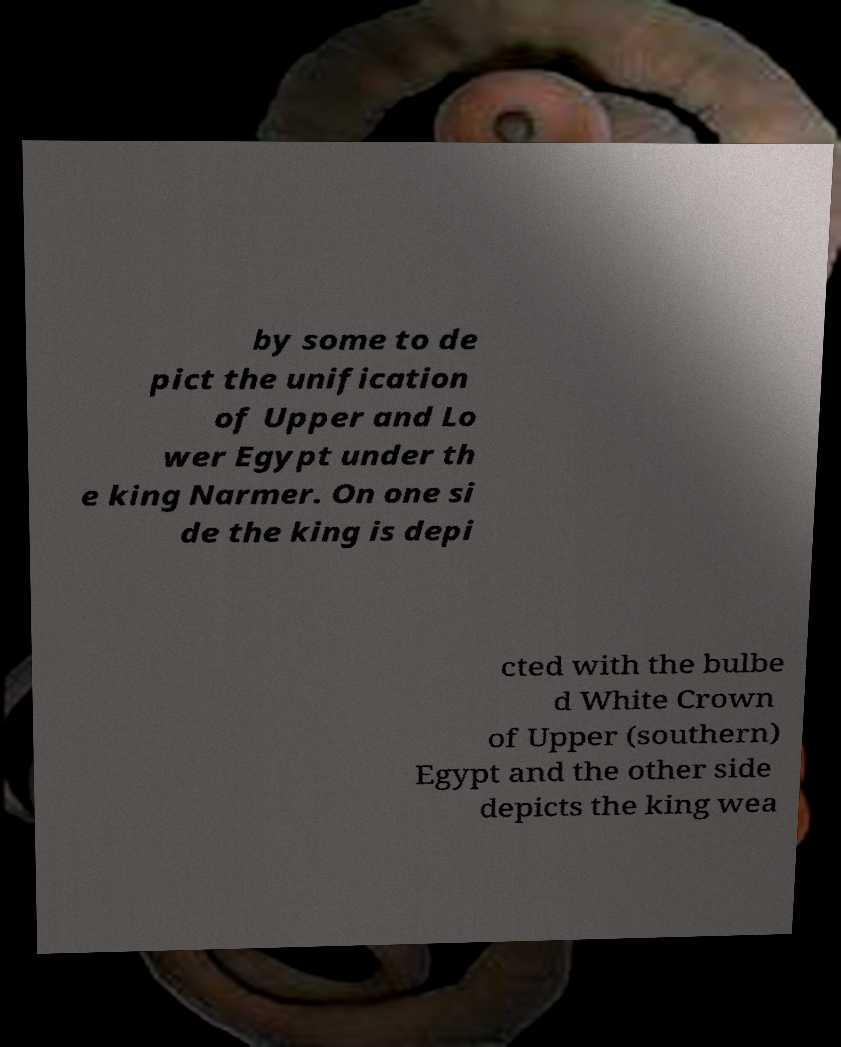Please read and relay the text visible in this image. What does it say? by some to de pict the unification of Upper and Lo wer Egypt under th e king Narmer. On one si de the king is depi cted with the bulbe d White Crown of Upper (southern) Egypt and the other side depicts the king wea 